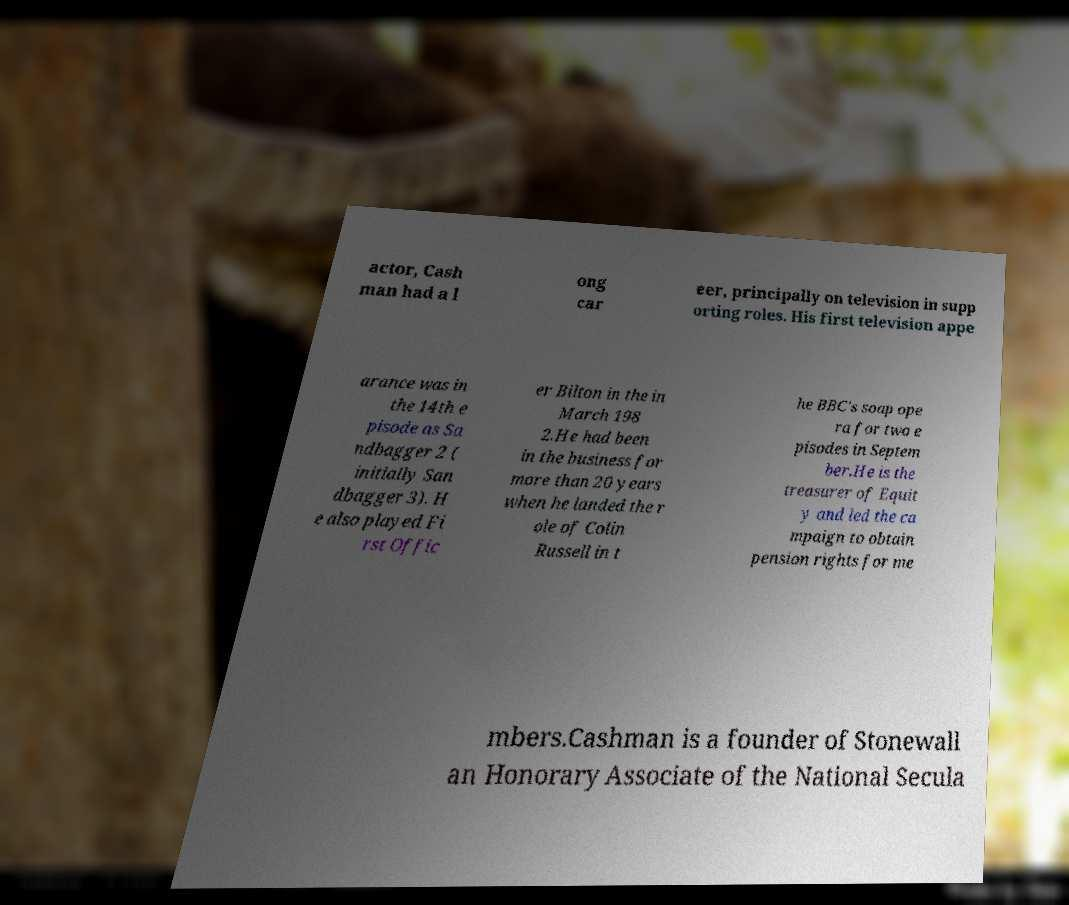Can you read and provide the text displayed in the image?This photo seems to have some interesting text. Can you extract and type it out for me? actor, Cash man had a l ong car eer, principally on television in supp orting roles. His first television appe arance was in the 14th e pisode as Sa ndbagger 2 ( initially San dbagger 3). H e also played Fi rst Offic er Bilton in the in March 198 2.He had been in the business for more than 20 years when he landed the r ole of Colin Russell in t he BBC's soap ope ra for two e pisodes in Septem ber.He is the treasurer of Equit y and led the ca mpaign to obtain pension rights for me mbers.Cashman is a founder of Stonewall an Honorary Associate of the National Secula 